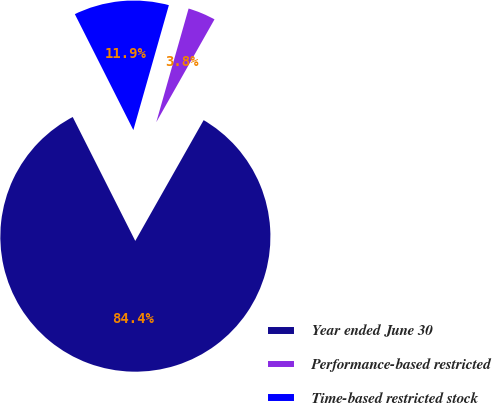Convert chart. <chart><loc_0><loc_0><loc_500><loc_500><pie_chart><fcel>Year ended June 30<fcel>Performance-based restricted<fcel>Time-based restricted stock<nl><fcel>84.36%<fcel>3.79%<fcel>11.85%<nl></chart> 